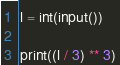<code> <loc_0><loc_0><loc_500><loc_500><_Python_>l = int(input())

print((l / 3) ** 3)</code> 